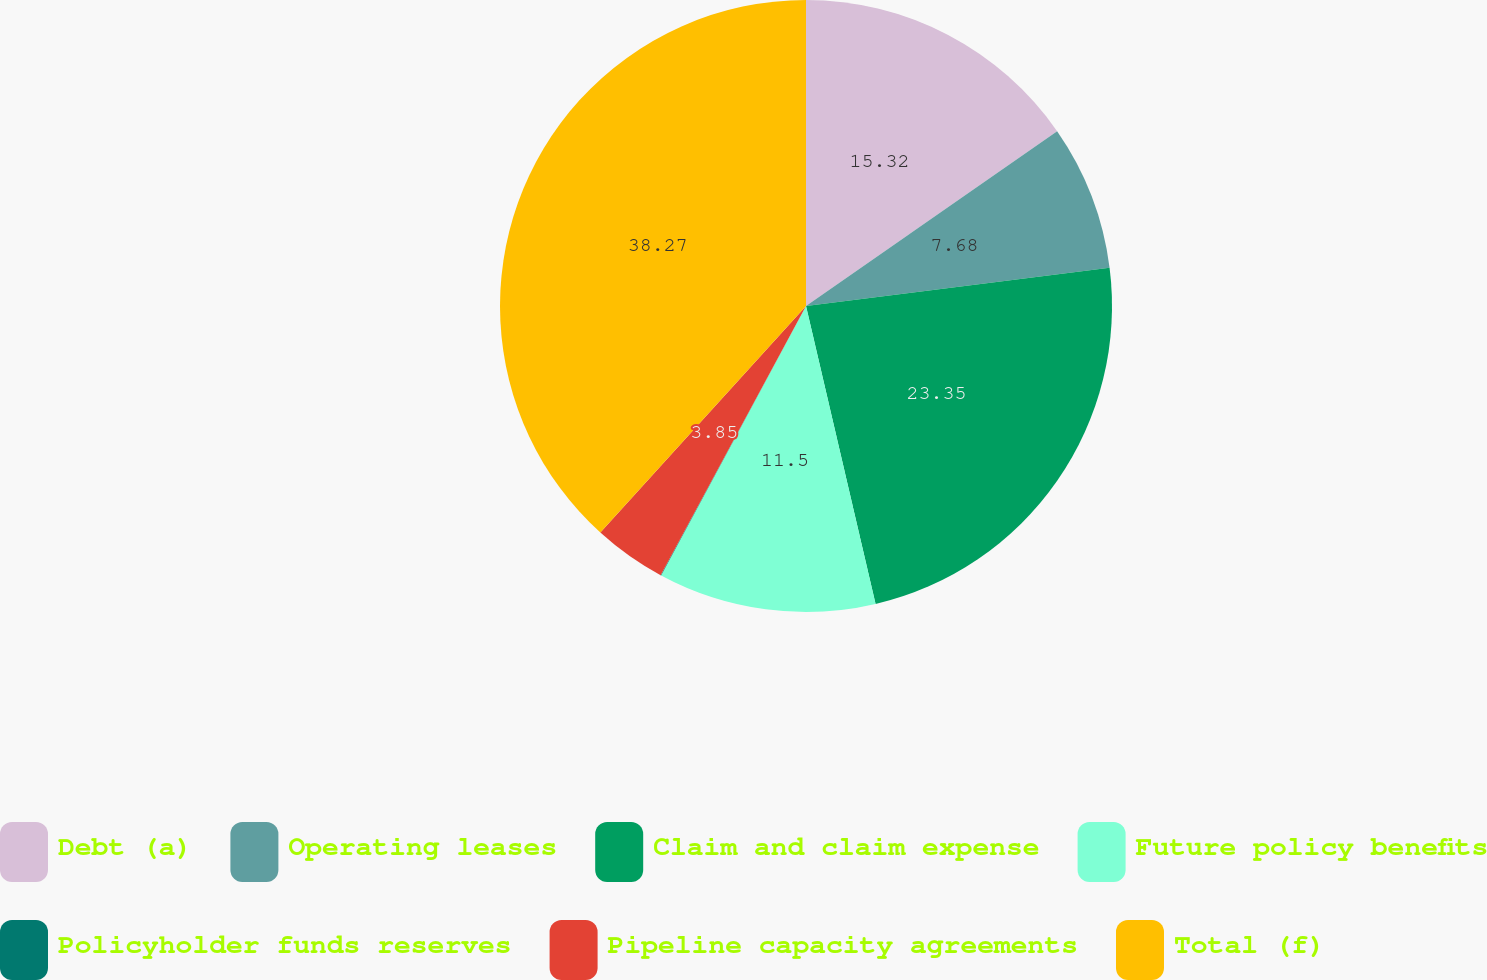Convert chart. <chart><loc_0><loc_0><loc_500><loc_500><pie_chart><fcel>Debt (a)<fcel>Operating leases<fcel>Claim and claim expense<fcel>Future policy benefits<fcel>Policyholder funds reserves<fcel>Pipeline capacity agreements<fcel>Total (f)<nl><fcel>15.32%<fcel>7.68%<fcel>23.35%<fcel>11.5%<fcel>0.03%<fcel>3.85%<fcel>38.27%<nl></chart> 